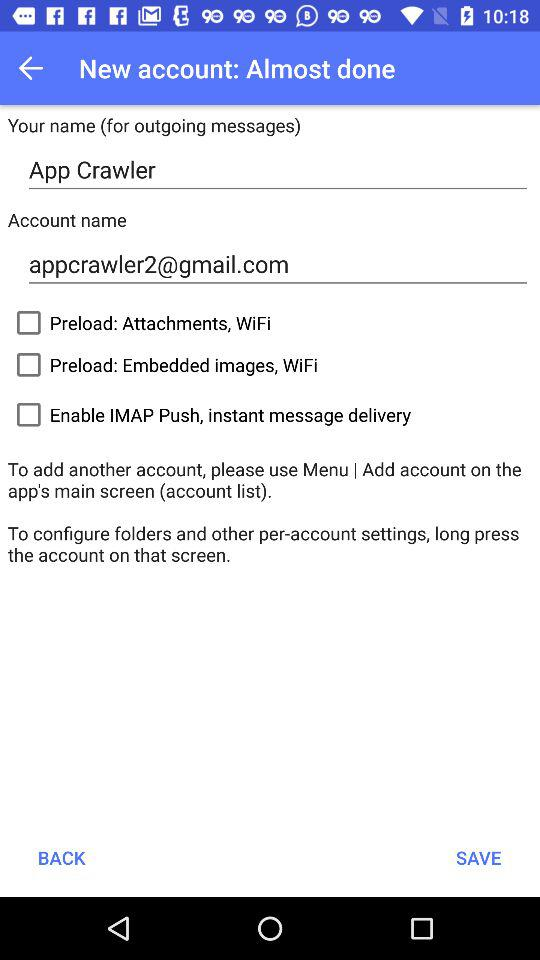How many checkboxes are there for enabling different features?
Answer the question using a single word or phrase. 3 